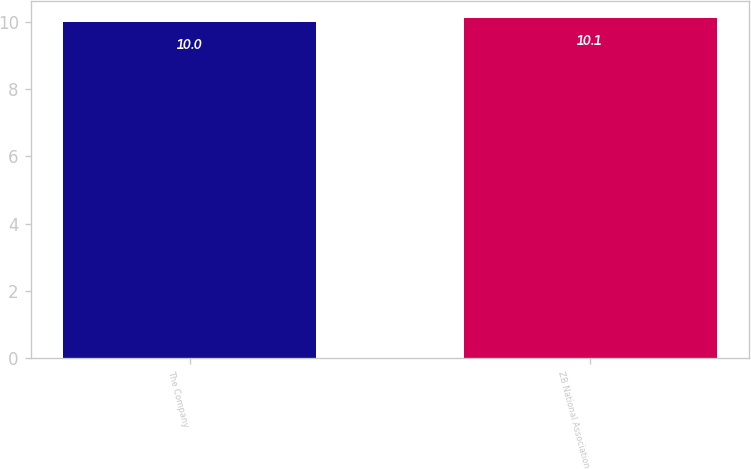<chart> <loc_0><loc_0><loc_500><loc_500><bar_chart><fcel>The Company<fcel>ZB National Association<nl><fcel>10<fcel>10.1<nl></chart> 